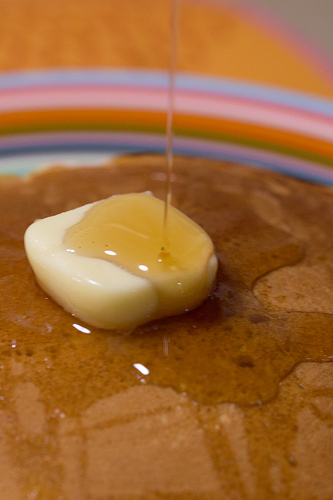<image>
Is the food on the table? Yes. Looking at the image, I can see the food is positioned on top of the table, with the table providing support. Is the butter on the plate? No. The butter is not positioned on the plate. They may be near each other, but the butter is not supported by or resting on top of the plate. 